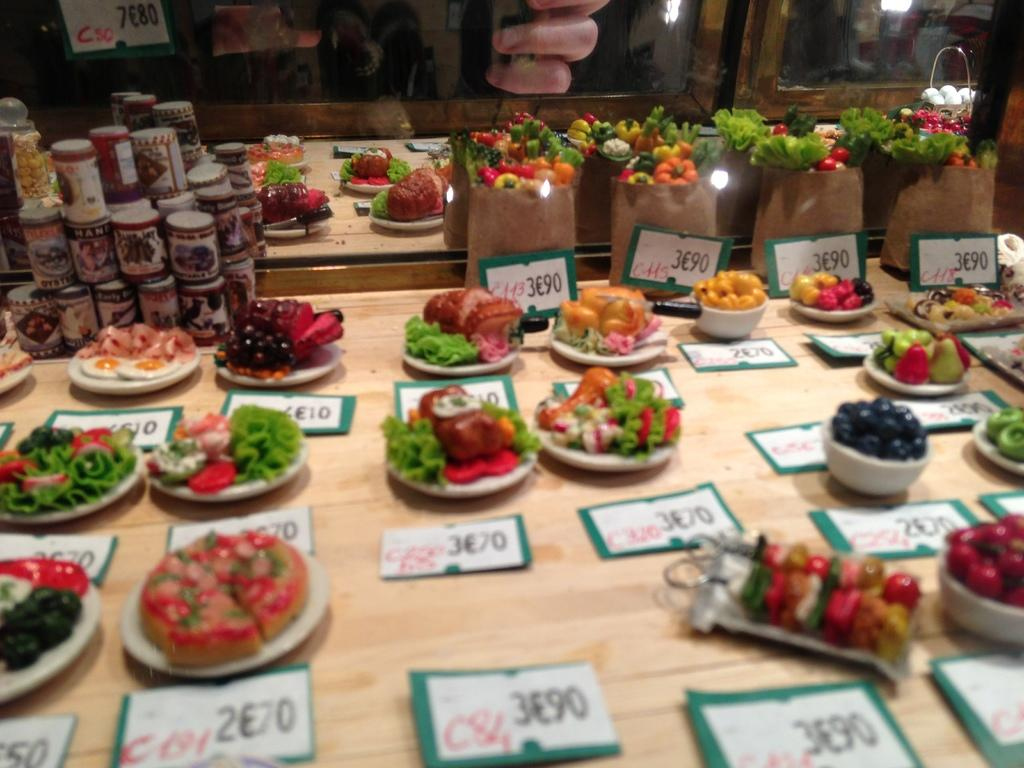What is the main object in the center of the image? There is a table in the center of the image. What items can be seen on the table? There are plates, fruits, desserts, jars, bags, and cakes on the table. What type of food is present on the table? There is food placed on the table, including fruits, desserts, and cakes. What else can be seen in the image besides the table and its contents? There are boards visible in the image. What type of milk can be seen in the image? There is no milk present in the image. 